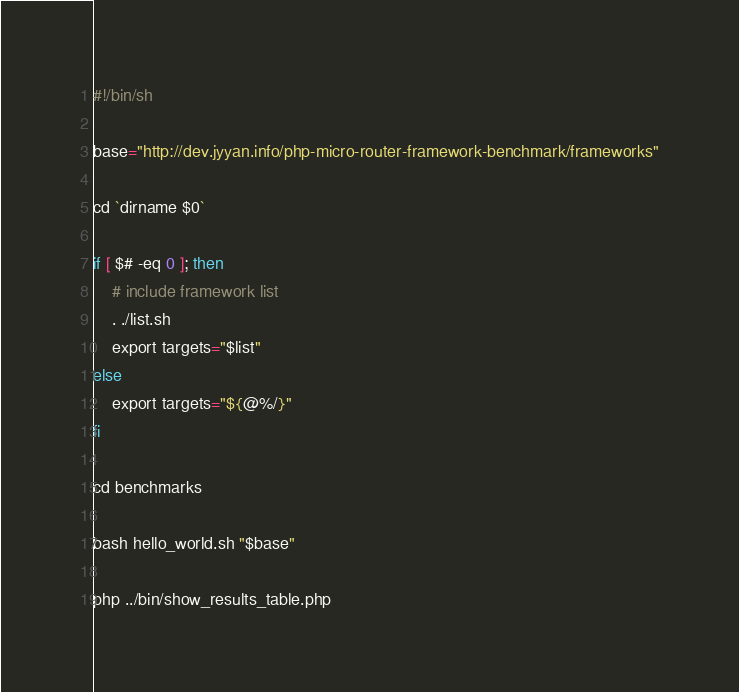Convert code to text. <code><loc_0><loc_0><loc_500><loc_500><_Bash_>#!/bin/sh

base="http://dev.jyyan.info/php-micro-router-framework-benchmark/frameworks"

cd `dirname $0`

if [ $# -eq 0 ]; then
    # include framework list
    . ./list.sh
    export targets="$list"
else
    export targets="${@%/}"
fi

cd benchmarks

bash hello_world.sh "$base"

php ../bin/show_results_table.php
</code> 